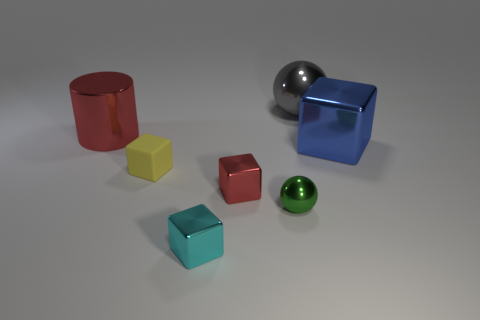What number of other objects are the same color as the cylinder?
Your response must be concise. 1. What is the big gray ball made of?
Ensure brevity in your answer.  Metal. What is the large thing that is to the right of the big cylinder and in front of the gray object made of?
Keep it short and to the point. Metal. How many objects are big shiny objects left of the red cube or large red metallic spheres?
Provide a short and direct response. 1. Is the cylinder the same color as the tiny ball?
Give a very brief answer. No. Is there a cyan shiny thing that has the same size as the blue object?
Offer a very short reply. No. What number of metallic objects are both behind the matte thing and to the right of the small cyan thing?
Ensure brevity in your answer.  2. How many objects are to the left of the large blue metal object?
Give a very brief answer. 6. Are there any other green metal things that have the same shape as the tiny green object?
Provide a short and direct response. No. There is a cyan metallic thing; is it the same shape as the red metal object in front of the big cube?
Make the answer very short. Yes. 